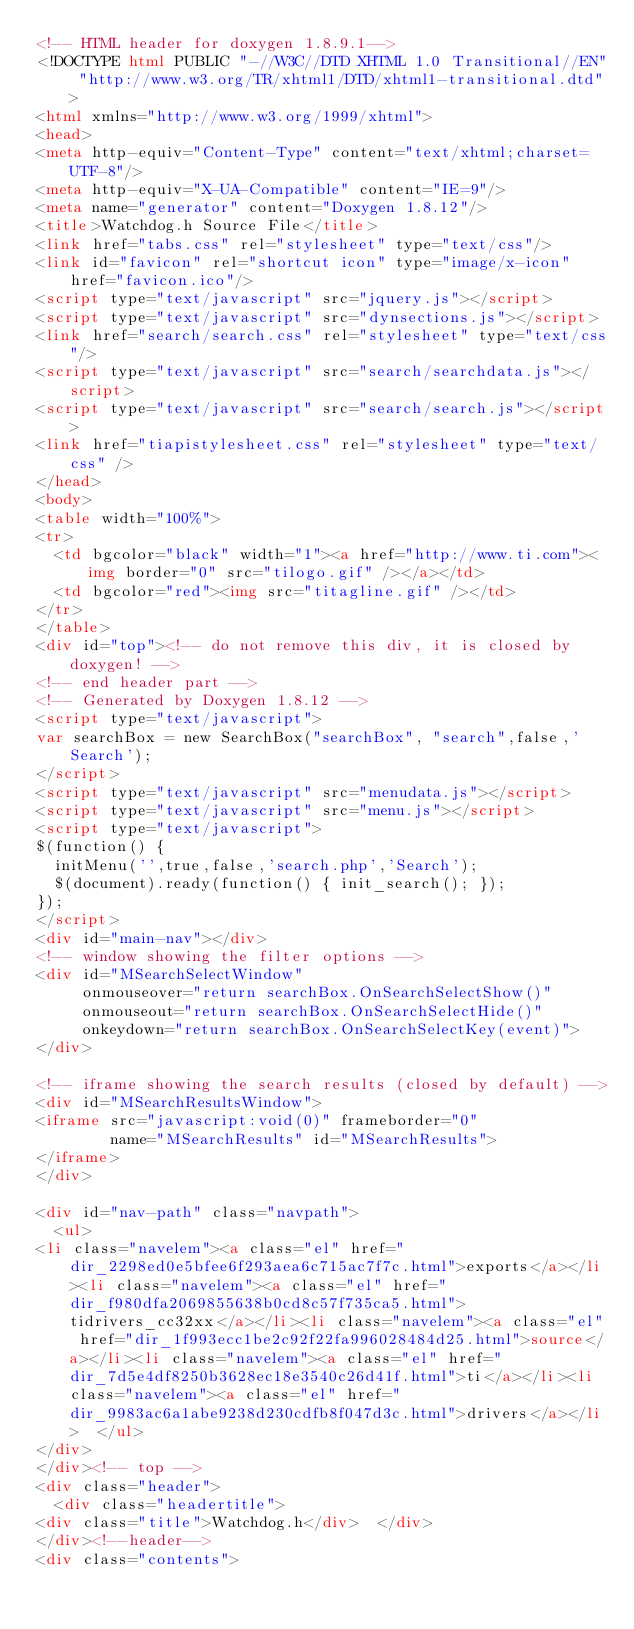Convert code to text. <code><loc_0><loc_0><loc_500><loc_500><_HTML_><!-- HTML header for doxygen 1.8.9.1-->
<!DOCTYPE html PUBLIC "-//W3C//DTD XHTML 1.0 Transitional//EN" "http://www.w3.org/TR/xhtml1/DTD/xhtml1-transitional.dtd">
<html xmlns="http://www.w3.org/1999/xhtml">
<head>
<meta http-equiv="Content-Type" content="text/xhtml;charset=UTF-8"/>
<meta http-equiv="X-UA-Compatible" content="IE=9"/>
<meta name="generator" content="Doxygen 1.8.12"/>
<title>Watchdog.h Source File</title>
<link href="tabs.css" rel="stylesheet" type="text/css"/>
<link id="favicon" rel="shortcut icon" type="image/x-icon" href="favicon.ico"/>
<script type="text/javascript" src="jquery.js"></script>
<script type="text/javascript" src="dynsections.js"></script>
<link href="search/search.css" rel="stylesheet" type="text/css"/>
<script type="text/javascript" src="search/searchdata.js"></script>
<script type="text/javascript" src="search/search.js"></script>
<link href="tiapistylesheet.css" rel="stylesheet" type="text/css" />
</head>
<body>
<table width="100%">
<tr>
  <td bgcolor="black" width="1"><a href="http://www.ti.com"><img border="0" src="tilogo.gif" /></a></td>
  <td bgcolor="red"><img src="titagline.gif" /></td>
</tr>
</table>
<div id="top"><!-- do not remove this div, it is closed by doxygen! -->
<!-- end header part -->
<!-- Generated by Doxygen 1.8.12 -->
<script type="text/javascript">
var searchBox = new SearchBox("searchBox", "search",false,'Search');
</script>
<script type="text/javascript" src="menudata.js"></script>
<script type="text/javascript" src="menu.js"></script>
<script type="text/javascript">
$(function() {
  initMenu('',true,false,'search.php','Search');
  $(document).ready(function() { init_search(); });
});
</script>
<div id="main-nav"></div>
<!-- window showing the filter options -->
<div id="MSearchSelectWindow"
     onmouseover="return searchBox.OnSearchSelectShow()"
     onmouseout="return searchBox.OnSearchSelectHide()"
     onkeydown="return searchBox.OnSearchSelectKey(event)">
</div>

<!-- iframe showing the search results (closed by default) -->
<div id="MSearchResultsWindow">
<iframe src="javascript:void(0)" frameborder="0" 
        name="MSearchResults" id="MSearchResults">
</iframe>
</div>

<div id="nav-path" class="navpath">
  <ul>
<li class="navelem"><a class="el" href="dir_2298ed0e5bfee6f293aea6c715ac7f7c.html">exports</a></li><li class="navelem"><a class="el" href="dir_f980dfa2069855638b0cd8c57f735ca5.html">tidrivers_cc32xx</a></li><li class="navelem"><a class="el" href="dir_1f993ecc1be2c92f22fa996028484d25.html">source</a></li><li class="navelem"><a class="el" href="dir_7d5e4df8250b3628ec18e3540c26d41f.html">ti</a></li><li class="navelem"><a class="el" href="dir_9983ac6a1abe9238d230cdfb8f047d3c.html">drivers</a></li>  </ul>
</div>
</div><!-- top -->
<div class="header">
  <div class="headertitle">
<div class="title">Watchdog.h</div>  </div>
</div><!--header-->
<div class="contents"></code> 